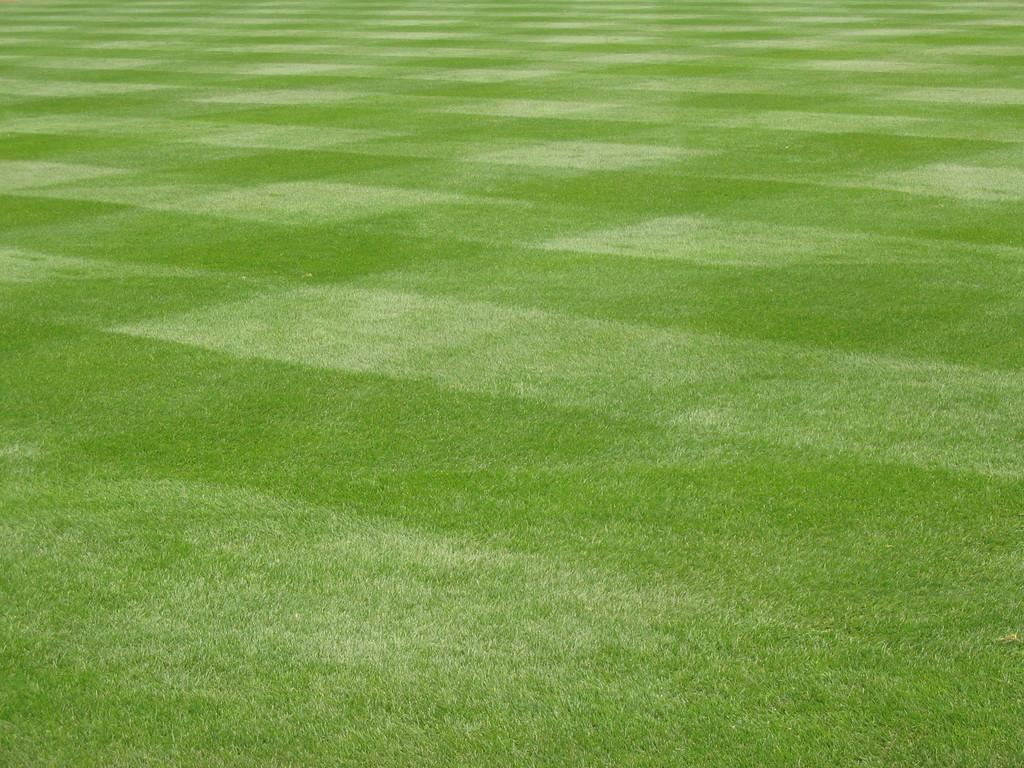What is the main subject of the picture? The main subject of the picture is a playground. What type of surface is on the floor of the playground? There is grass on the floor of the playground. What type of territory is being claimed by the playground in the image? There is no indication of territory being claimed in the image; it simply shows a playground with grass on the floor. How does the playground shake in the image? The playground does not shake in the image; it is stationary. 